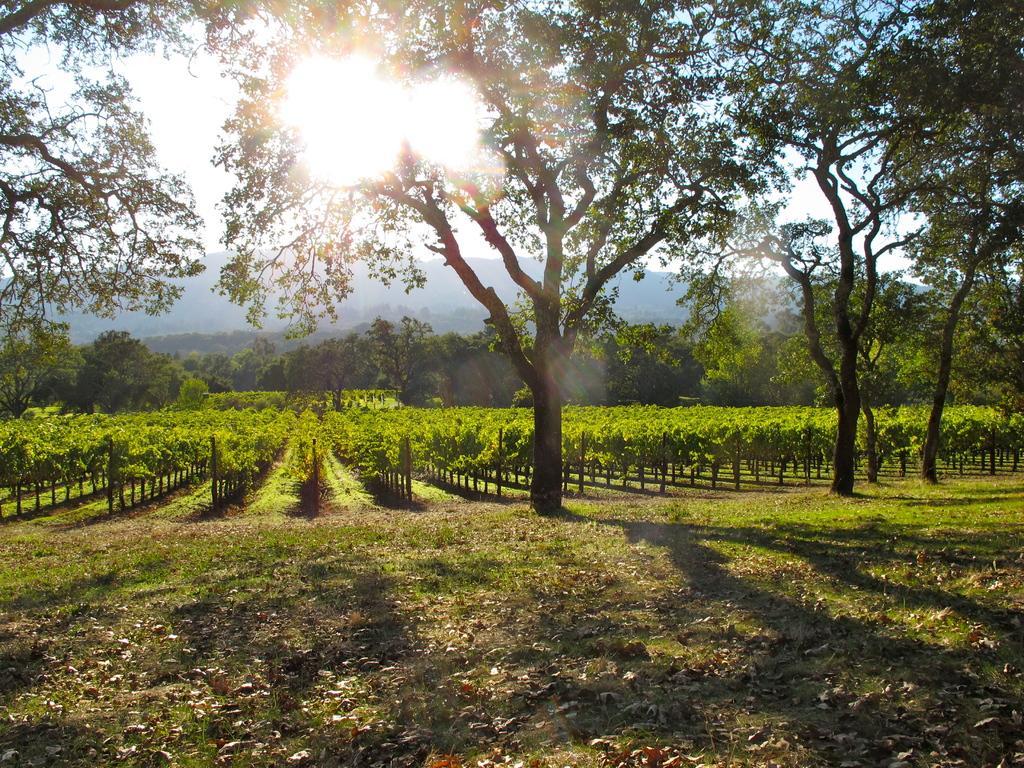Please provide a concise description of this image. In this image I can see few trees and plants in green color. In the background I can see the sky in white color. 